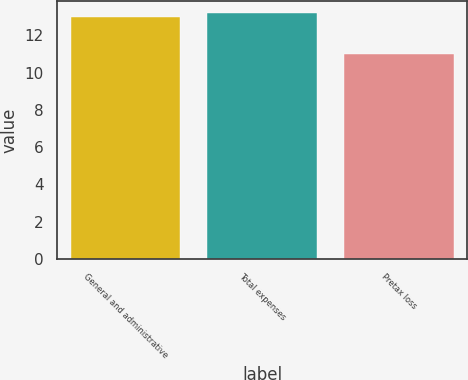<chart> <loc_0><loc_0><loc_500><loc_500><bar_chart><fcel>General and administrative<fcel>Total expenses<fcel>Pretax loss<nl><fcel>13<fcel>13.2<fcel>11<nl></chart> 